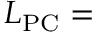Convert formula to latex. <formula><loc_0><loc_0><loc_500><loc_500>L _ { P C } =</formula> 